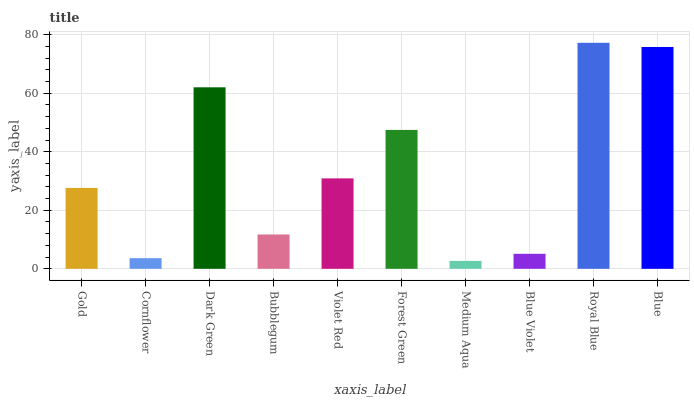Is Medium Aqua the minimum?
Answer yes or no. Yes. Is Royal Blue the maximum?
Answer yes or no. Yes. Is Cornflower the minimum?
Answer yes or no. No. Is Cornflower the maximum?
Answer yes or no. No. Is Gold greater than Cornflower?
Answer yes or no. Yes. Is Cornflower less than Gold?
Answer yes or no. Yes. Is Cornflower greater than Gold?
Answer yes or no. No. Is Gold less than Cornflower?
Answer yes or no. No. Is Violet Red the high median?
Answer yes or no. Yes. Is Gold the low median?
Answer yes or no. Yes. Is Blue the high median?
Answer yes or no. No. Is Medium Aqua the low median?
Answer yes or no. No. 